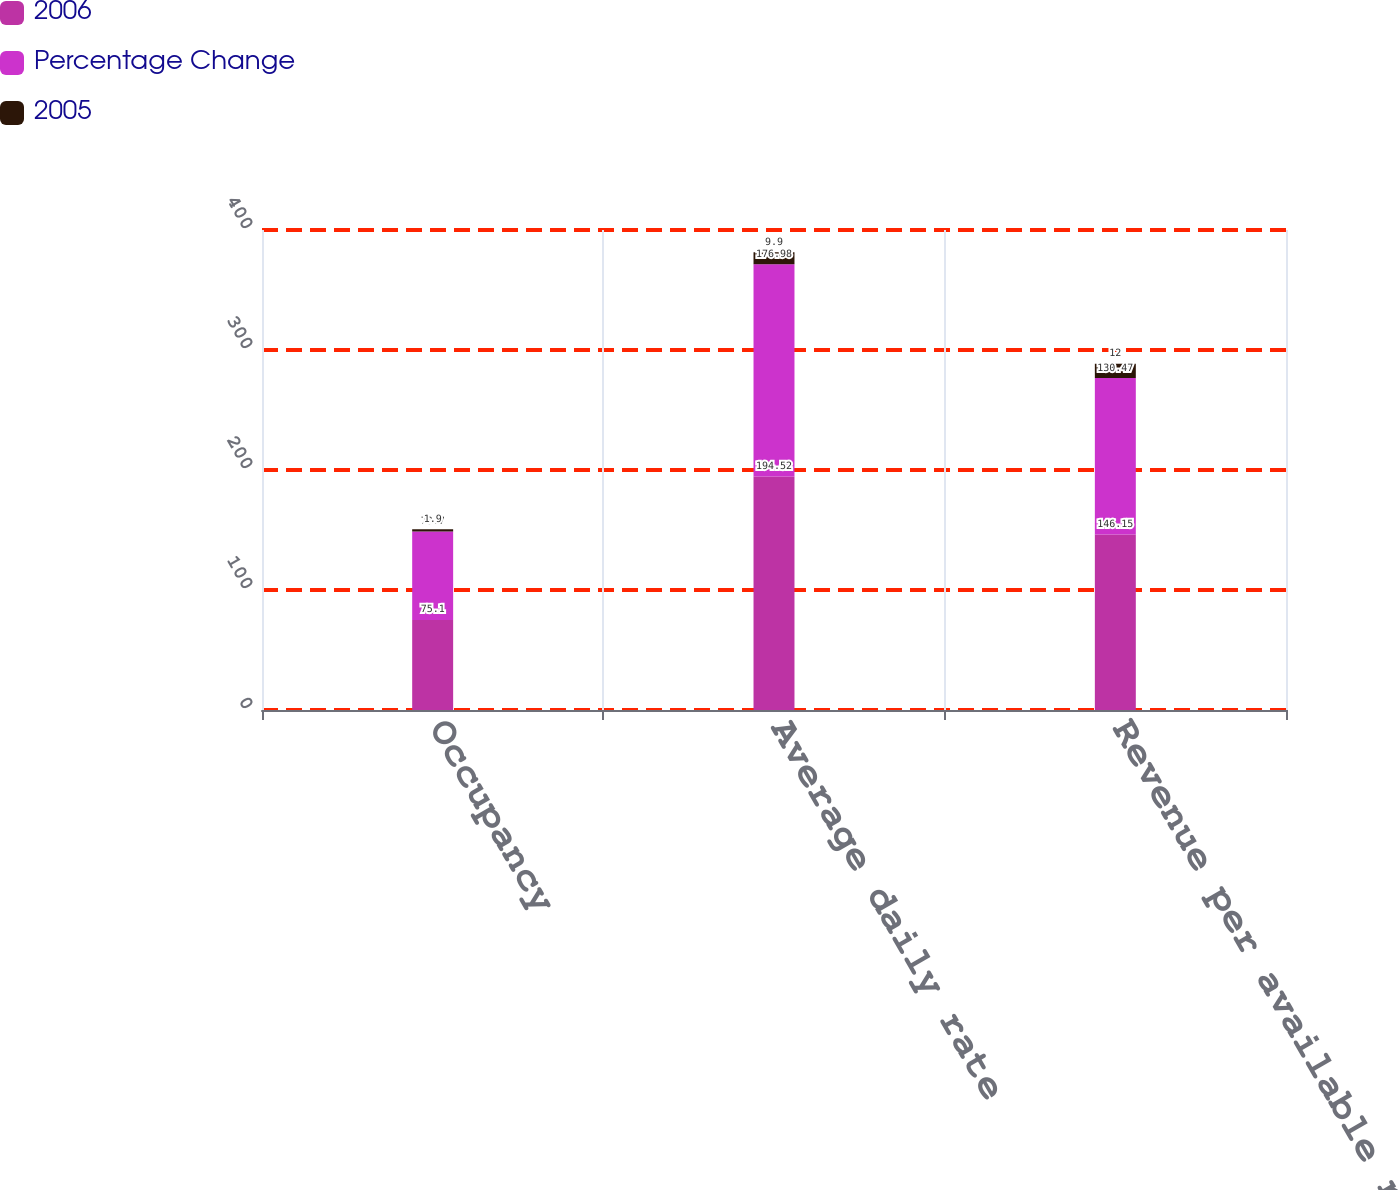Convert chart. <chart><loc_0><loc_0><loc_500><loc_500><stacked_bar_chart><ecel><fcel>Occupancy<fcel>Average daily rate<fcel>Revenue per available room<nl><fcel>2006<fcel>75.1<fcel>194.52<fcel>146.15<nl><fcel>Percentage Change<fcel>73.7<fcel>176.98<fcel>130.47<nl><fcel>2005<fcel>1.9<fcel>9.9<fcel>12<nl></chart> 